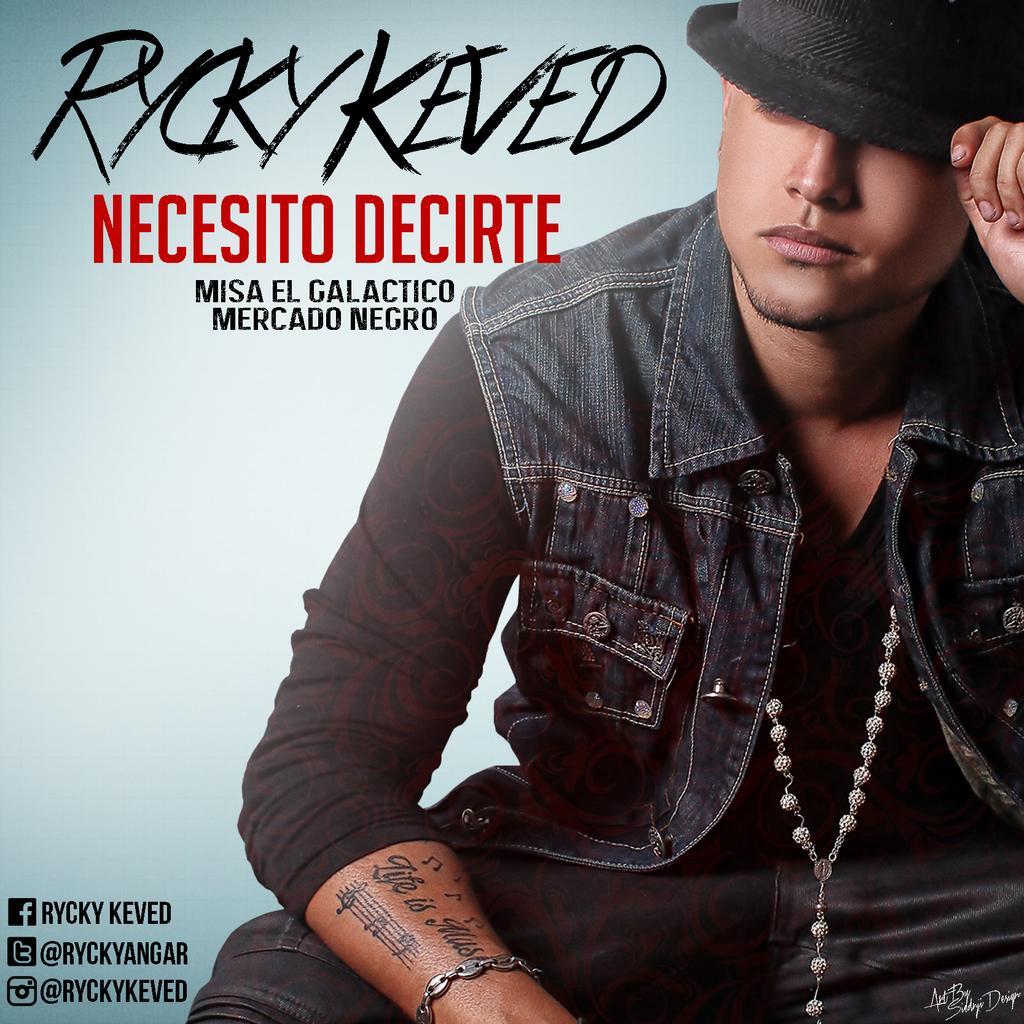Could you give a brief overview of what you see in this image? In this image I can see a man. The man is wearing black color hat, jacket and some other object. Here I can see something written on the image. 